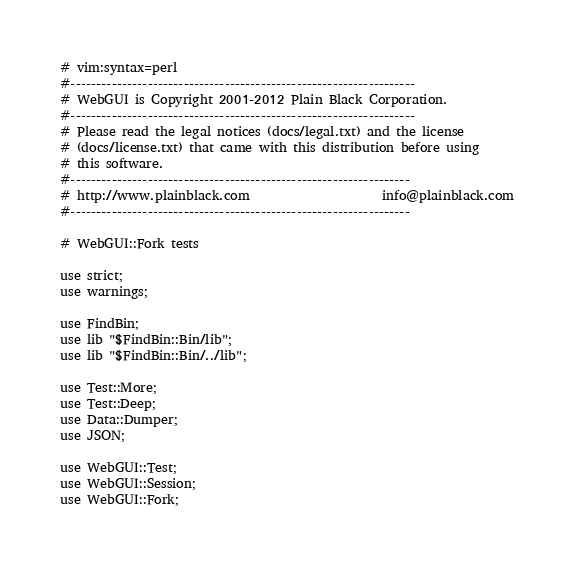<code> <loc_0><loc_0><loc_500><loc_500><_Perl_># vim:syntax=perl
#-------------------------------------------------------------------
# WebGUI is Copyright 2001-2012 Plain Black Corporation.
#-------------------------------------------------------------------
# Please read the legal notices (docs/legal.txt) and the license
# (docs/license.txt) that came with this distribution before using
# this software.
#------------------------------------------------------------------
# http://www.plainblack.com                     info@plainblack.com
#------------------------------------------------------------------

# WebGUI::Fork tests

use strict;
use warnings;

use FindBin;
use lib "$FindBin::Bin/lib";
use lib "$FindBin::Bin/../lib";

use Test::More;
use Test::Deep;
use Data::Dumper;
use JSON;

use WebGUI::Test;
use WebGUI::Session;
use WebGUI::Fork;
</code> 